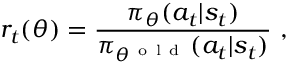<formula> <loc_0><loc_0><loc_500><loc_500>r _ { t } ( \theta ) = \frac { \pi _ { \theta } ( a _ { t } | s _ { t } ) } { \pi _ { \theta ^ { o l d } } ( a _ { t } | s _ { t } ) } ,</formula> 